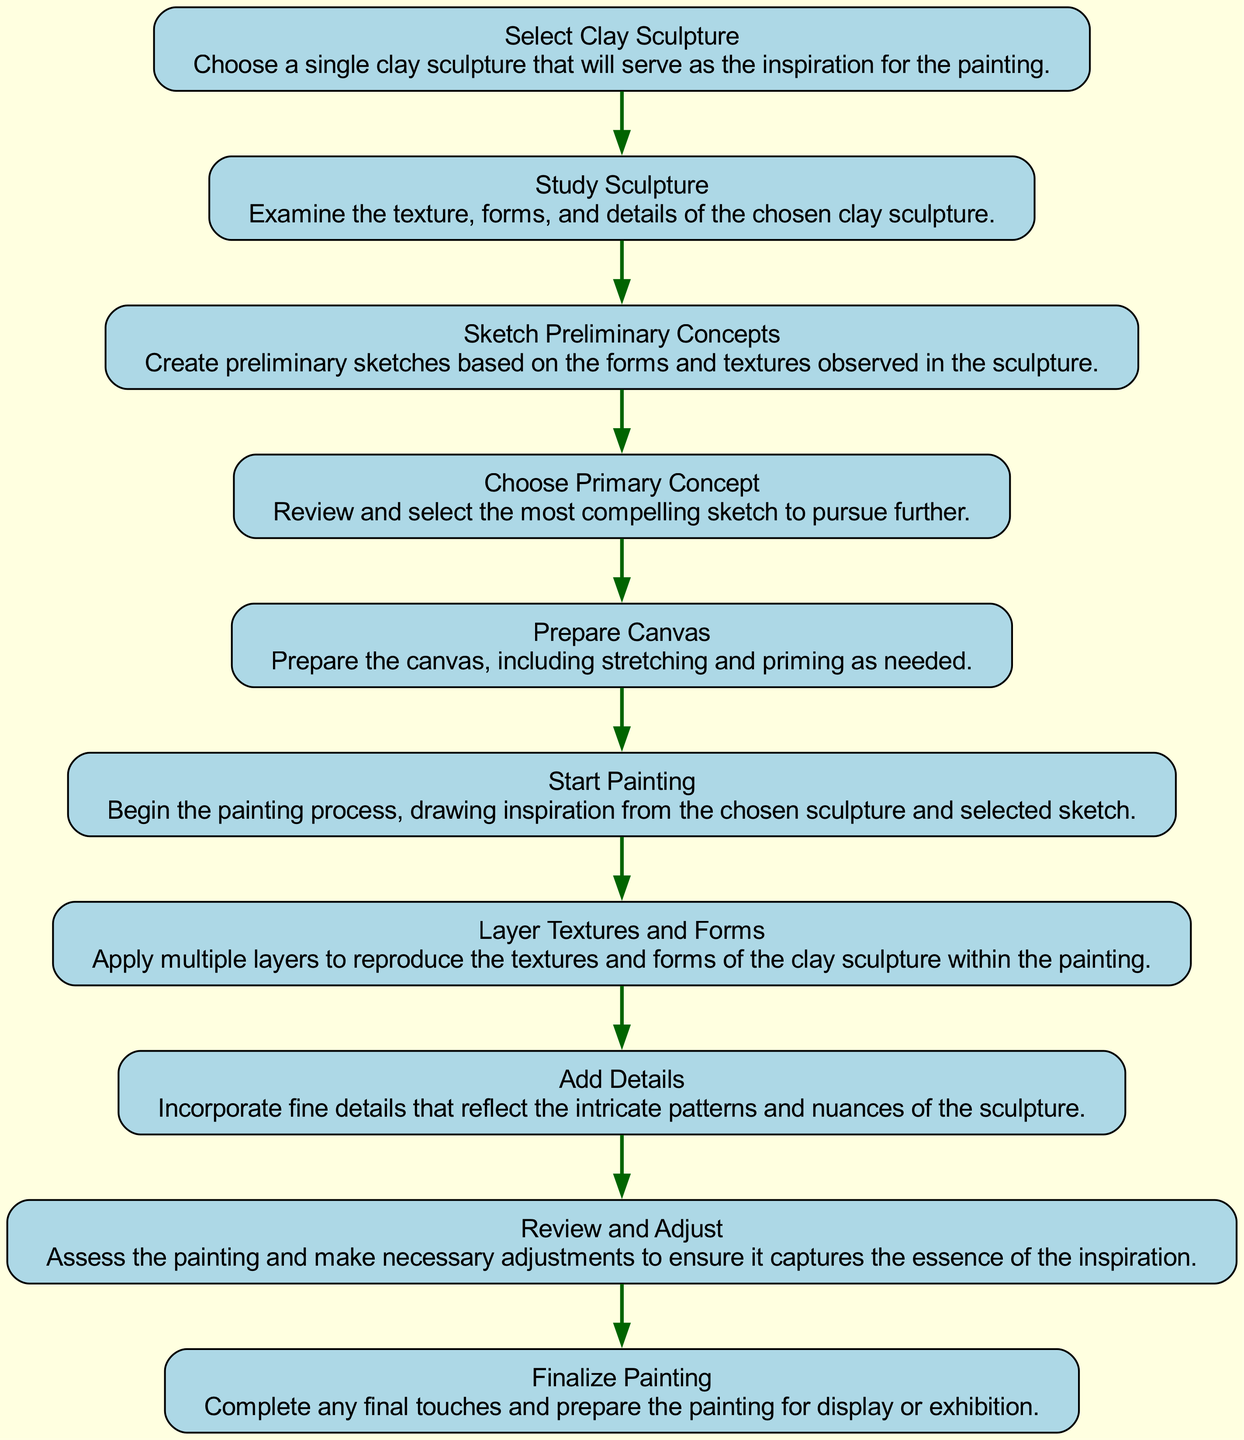What is the last step in the painting process? The last step in the diagram is labeled as "Finalize Painting." This node indicates that the painting is completed with any final touches before displaying or exhibiting it.
Answer: Finalize Painting How many total elements are in the flow chart? There are ten elements listed in the diagram, each representing a step in the evolution of the painting inspired by the clay sculpture.
Answer: Ten What action follows "Add Details"? According to the flow of the diagram, the action that follows "Add Details" is "Review and Adjust," which assesses the painting and makes necessary adjustments.
Answer: Review and Adjust What is the dependency of "Prepare Canvas"? The action "Prepare Canvas" depends on "Choose Primary Concept," meaning that you must first choose a concept before preparing the canvas for painting.
Answer: Choose Primary Concept Which action is connected to "Study Sculpture"? The action directly connected to "Study Sculpture" is "Sketch Preliminary Concepts," indicating that after studying the sculpture, preliminary sketches are created based on observations.
Answer: Sketch Preliminary Concepts What is the initial action in the process? The initial action in the evolution of the painting process is "Select Clay Sculpture," which starts the journey by choosing a sculpture for inspiration.
Answer: Select Clay Sculpture How many actions must be completed before "Finalize Painting"? To reach "Finalize Painting," nine actions must be completed sequentially, from selecting the sculpture to reviewing and adjusting the painting.
Answer: Nine What is the purpose of "Layer Textures and Forms"? The purpose of "Layer Textures and Forms" is to apply multiple layers in the painting to reproduce the textures and forms observed in the clay sculpture, enriching the painting's depth.
Answer: Apply multiple layers What step comes before "Start Painting"? The step that comes before "Start Painting" is "Prepare Canvas," which involves preparing the canvas needed to begin the actual painting process.
Answer: Prepare Canvas What does "Choose Primary Concept" aim to achieve? "Choose Primary Concept" aims to review and select the most compelling sketch from the preliminary concepts to continue the painting process based on that concept.
Answer: Select the most compelling sketch 